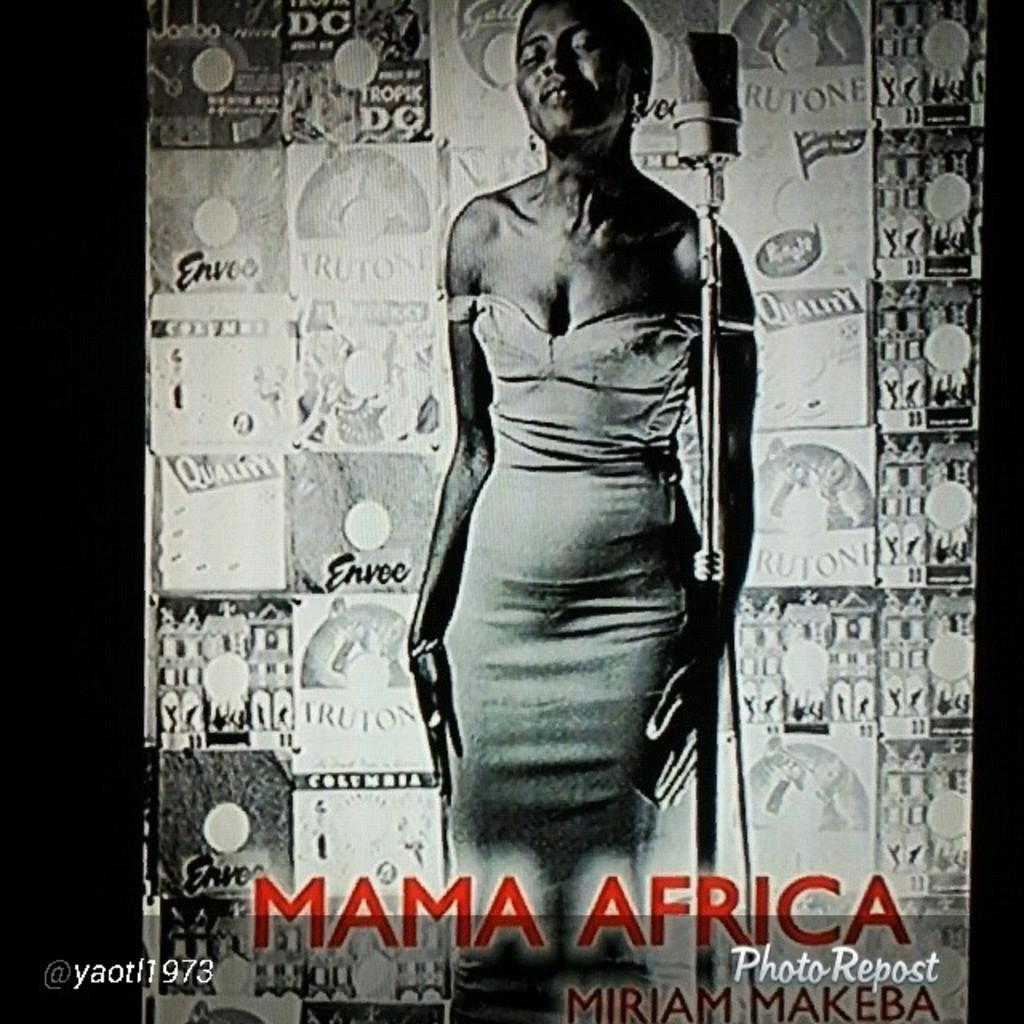What type of image is being described? The image is a poster. What is the main subject of the poster? There is a woman standing near a mic in the center of the poster. What can be seen in the background of the poster? There is a banner in the background of the poster. Where is the text located on the poster? The text is at the bottom of the poster. How many fans are visible in the image? There are no fans present in the image. What type of comb is the woman using in the image? There is no comb visible in the image, as the woman is not shown using any hair-related accessory. 